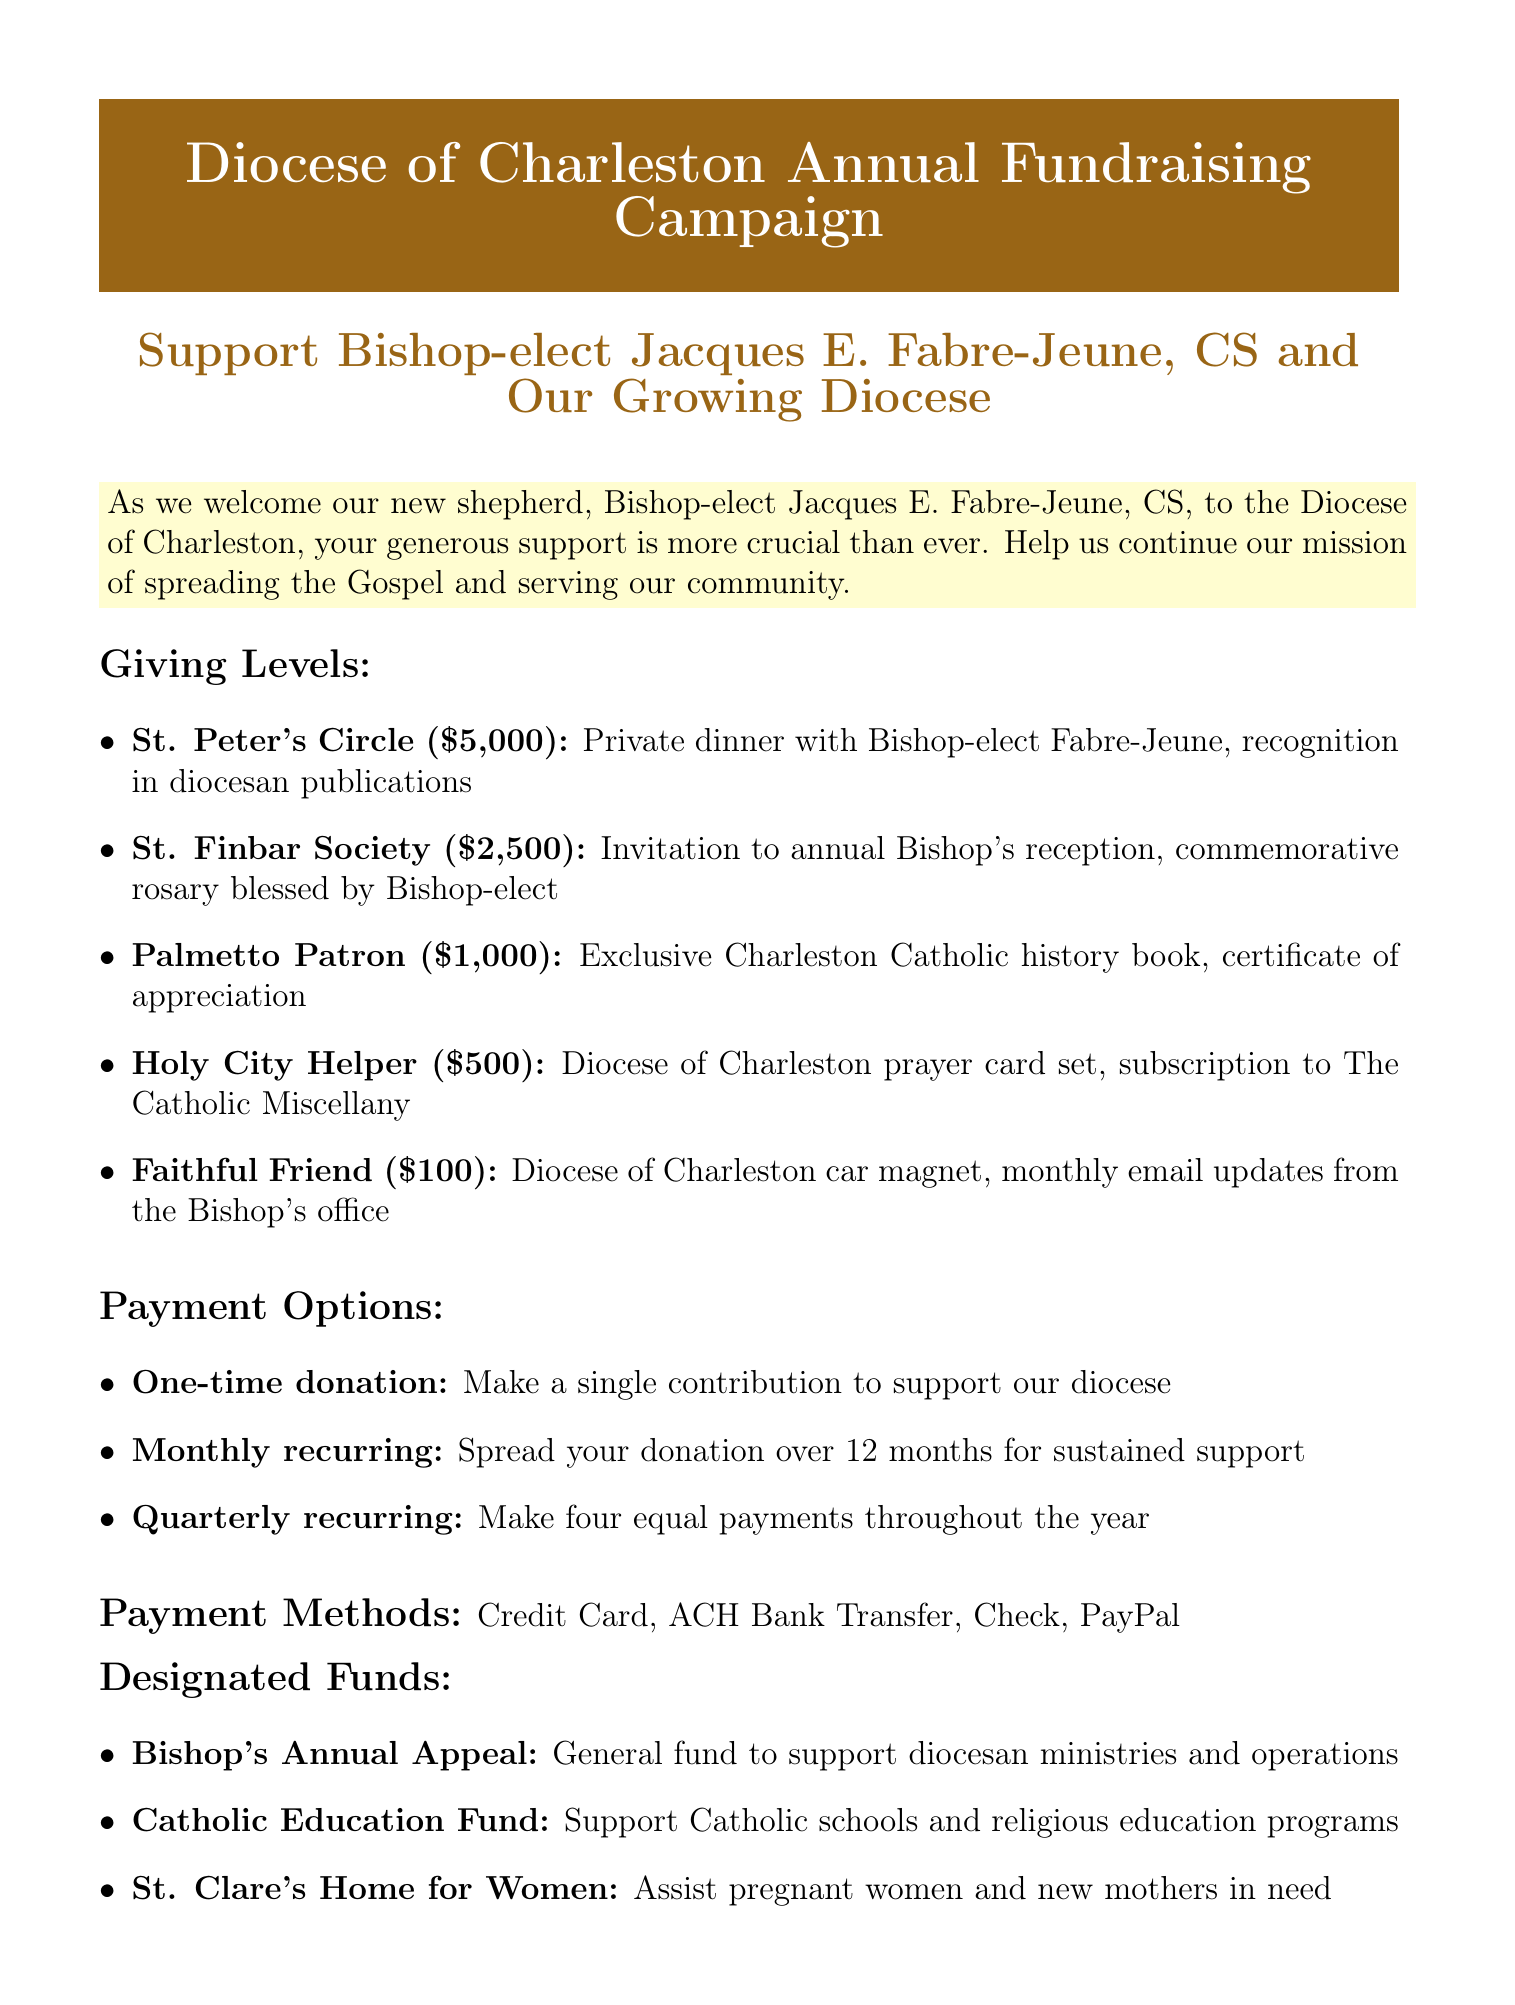what is the title of the form? The title is stated at the beginning of the document as the main header.
Answer: Diocese of Charleston Annual Fundraising Campaign who is the new bishop? The document mentions this person's name in the header.
Answer: Bishop-elect Jacques E. Fabre-Jeune, CS what is the minimum donation level? The giving levels section lists different amounts, and the lowest figure represents the minimum.
Answer: $100 what benefit do members of the St. Finbar Society receive? Benefits associated with donation levels are outlined in the giving levels section.
Answer: Invitation to annual Bishop's reception, commemorative rosary blessed by Bishop-elect how many payment options are available? The payment options section lists distinct methods of donating.
Answer: 3 which payment method is NOT listed? A careful review of the payment methods section can identify methods that are absent.
Answer: Venmo what fund supports Catholic schools? The designated funds section specifically names the fund for this purpose.
Answer: Catholic Education Fund what is the address for contacting the diocese? The document provides this information in the contact information section.
Answer: 901 Orange Grove Road, Charleston, SC 29407 what recurring donation option spreads payments over 12 months? This information can be found in the payment options section.
Answer: Monthly recurring 